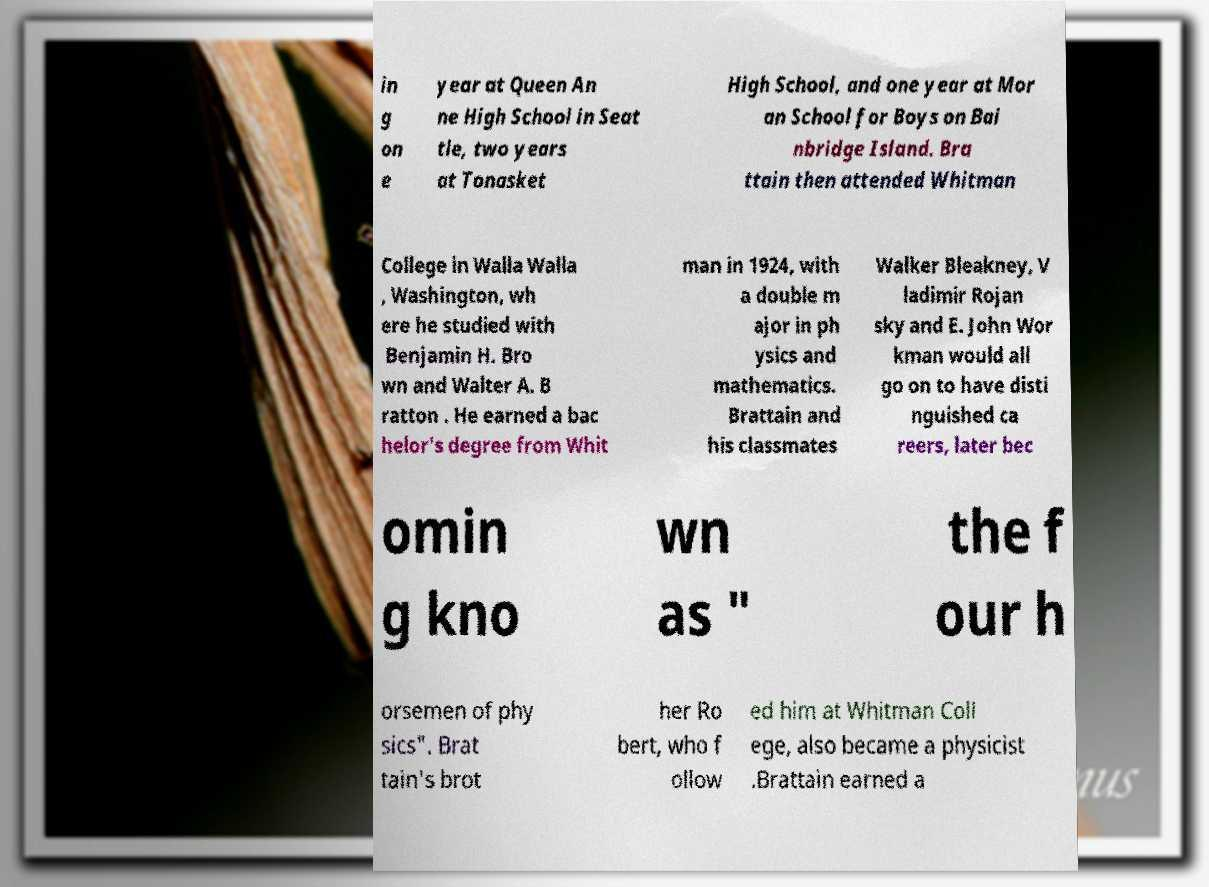Could you extract and type out the text from this image? in g on e year at Queen An ne High School in Seat tle, two years at Tonasket High School, and one year at Mor an School for Boys on Bai nbridge Island. Bra ttain then attended Whitman College in Walla Walla , Washington, wh ere he studied with Benjamin H. Bro wn and Walter A. B ratton . He earned a bac helor's degree from Whit man in 1924, with a double m ajor in ph ysics and mathematics. Brattain and his classmates Walker Bleakney, V ladimir Rojan sky and E. John Wor kman would all go on to have disti nguished ca reers, later bec omin g kno wn as " the f our h orsemen of phy sics". Brat tain's brot her Ro bert, who f ollow ed him at Whitman Coll ege, also became a physicist .Brattain earned a 